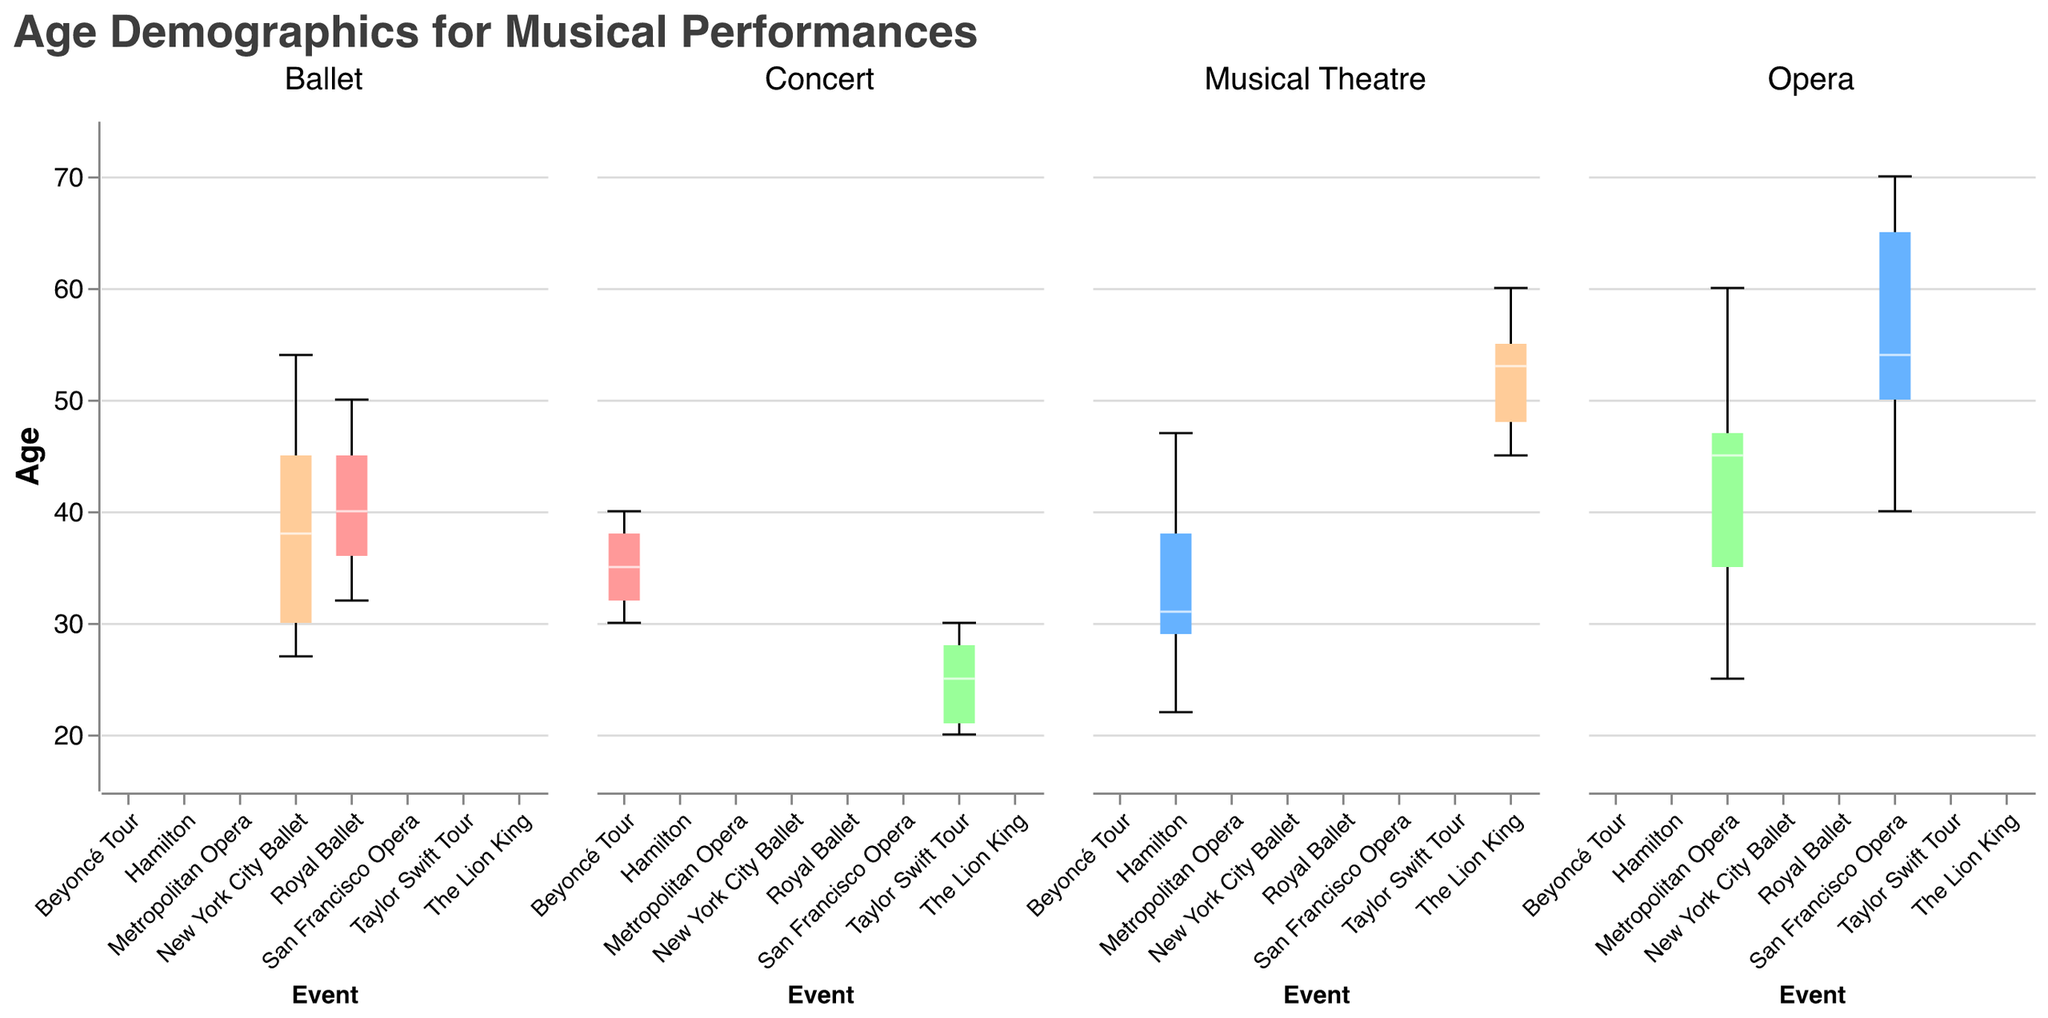What's the median age for the Metropolitan Opera? The median age is represented by a white line in the center of the box for the Metropolitan Opera section of the graph.
Answer: 45 Which event has the youngest median age in the Concert category? To find the youngest median age in the Concert category, look for the event in the Concert section with the lowest white line in the boxplot.
Answer: Taylor Swift Tour How does the median age for San Francisco Opera compare with Royal Ballet? Compare the white lines in the boxes for San Francisco Opera and Royal Ballet to see which is higher. The median age for San Francisco Opera is notably higher.
Answer: Higher What is the age range for Musical Theatre events? Look at the minimum and maximum whiskers in the Musical Theatre box plot. The minimum age is from Hamilton and the maximum age is from The Lion King.
Answer: From 22 to 60 Is there more variability in audience age for Beyoncé Tour or Hamilton? Assess the length of the boxes and whiskers for both Beyoncé Tour and Hamilton. The longer the total range, the more variability. Hamilton shows more variability with a wider range.
Answer: Hamilton Which event has the most compact age distribution in the Opera category? Look for the event in the Opera category with the shortest box (Interquartile Range). The Metropolitan Opera has a more compact age distribution compared to San Francisco Opera.
Answer: Metropolitan Opera What is the maximum age recorded for Taylor Swift Tour attendees? Look at the highest point of the whiskers for the Taylor Swift Tour in the Concert category.
Answer: 30 Are there audience members younger than 25 attending The Lion King performances? Check the minimum whisker or box edge for The Lion King in the Musical Theatre category. The youngest age listed here is 45, indicating no audience members are younger than 25.
Answer: No What’s the difference between the median ages of New York City Ballet and The Lion King? Find the median ages by looking at the white lines in the boxes for New York City Ballet (Ballet) and The Lion King (Musical Theatre). New York City Ballet's median age is 38, and The Lion King's is 53. Subtract 38 from 53.
Answer: 15 years 